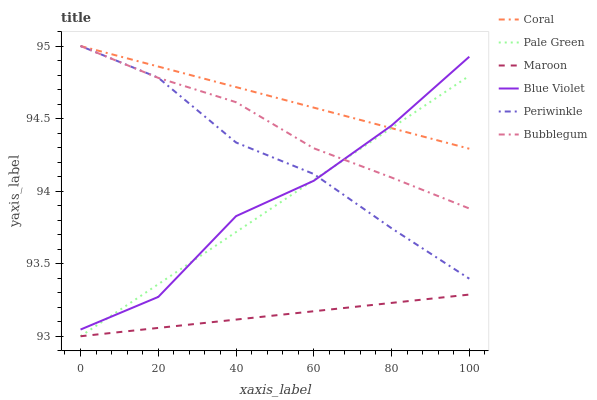Does Maroon have the minimum area under the curve?
Answer yes or no. Yes. Does Coral have the maximum area under the curve?
Answer yes or no. Yes. Does Pale Green have the minimum area under the curve?
Answer yes or no. No. Does Pale Green have the maximum area under the curve?
Answer yes or no. No. Is Maroon the smoothest?
Answer yes or no. Yes. Is Blue Violet the roughest?
Answer yes or no. Yes. Is Pale Green the smoothest?
Answer yes or no. No. Is Pale Green the roughest?
Answer yes or no. No. Does Maroon have the lowest value?
Answer yes or no. Yes. Does Periwinkle have the lowest value?
Answer yes or no. No. Does Bubblegum have the highest value?
Answer yes or no. Yes. Does Pale Green have the highest value?
Answer yes or no. No. Is Maroon less than Blue Violet?
Answer yes or no. Yes. Is Blue Violet greater than Maroon?
Answer yes or no. Yes. Does Bubblegum intersect Periwinkle?
Answer yes or no. Yes. Is Bubblegum less than Periwinkle?
Answer yes or no. No. Is Bubblegum greater than Periwinkle?
Answer yes or no. No. Does Maroon intersect Blue Violet?
Answer yes or no. No. 